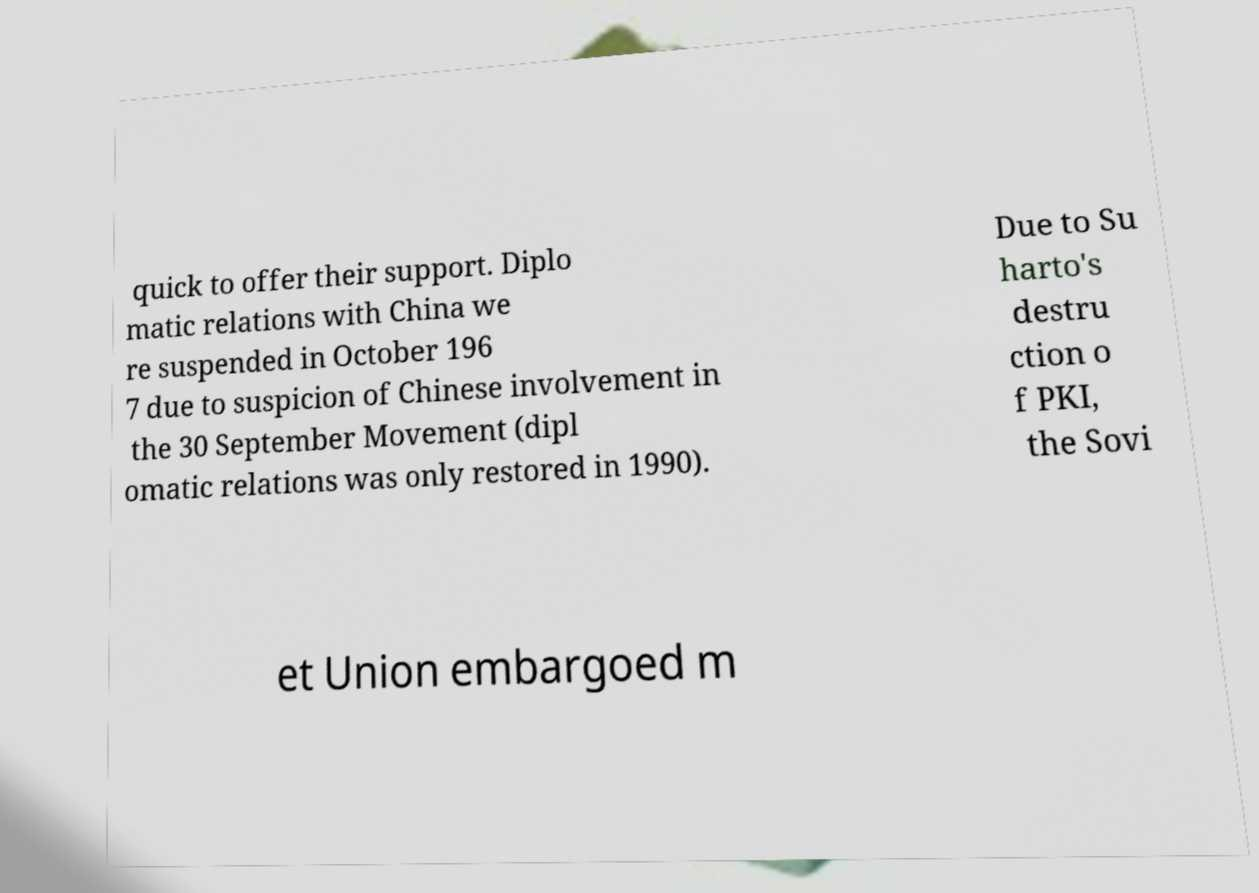For documentation purposes, I need the text within this image transcribed. Could you provide that? quick to offer their support. Diplo matic relations with China we re suspended in October 196 7 due to suspicion of Chinese involvement in the 30 September Movement (dipl omatic relations was only restored in 1990). Due to Su harto's destru ction o f PKI, the Sovi et Union embargoed m 